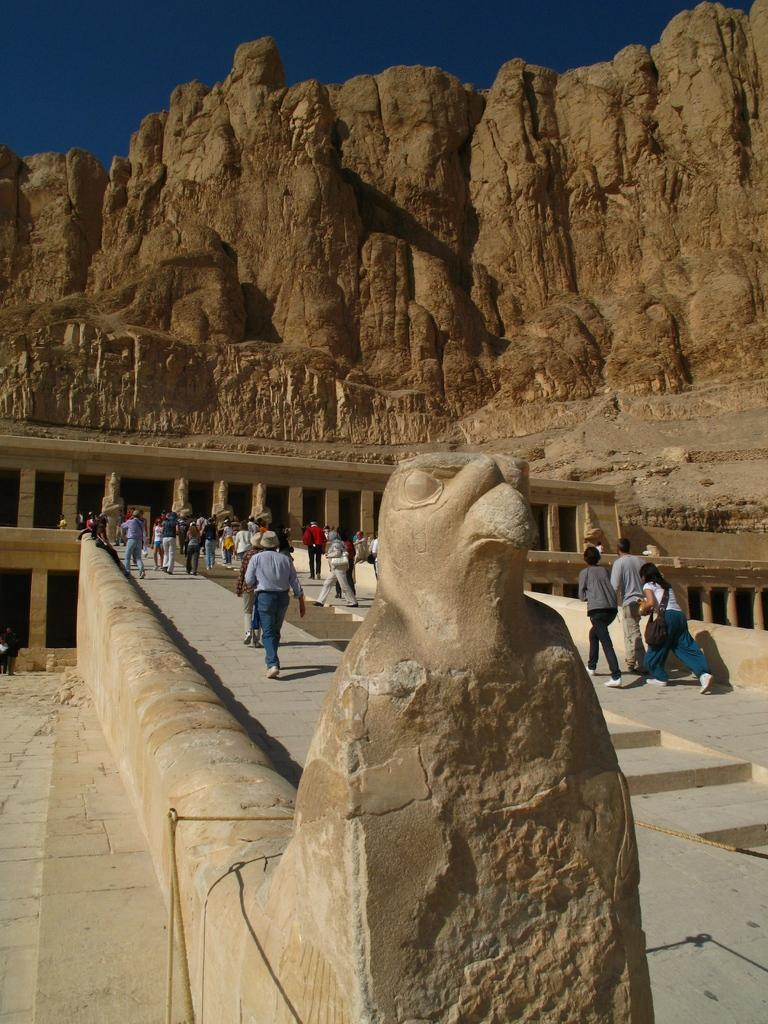What is the statue in the image shaped like? The statue is in the shape of a bird. What are the people near the statue doing? People are walking near the statue. What can be seen on the right side of the image? There are hills on the right side of the image. How many feathers are on the bird statue in the image? The image does not provide enough detail to determine the number of feathers on the bird statue. Additionally, statues are typically made of materials that do not have feathers. 